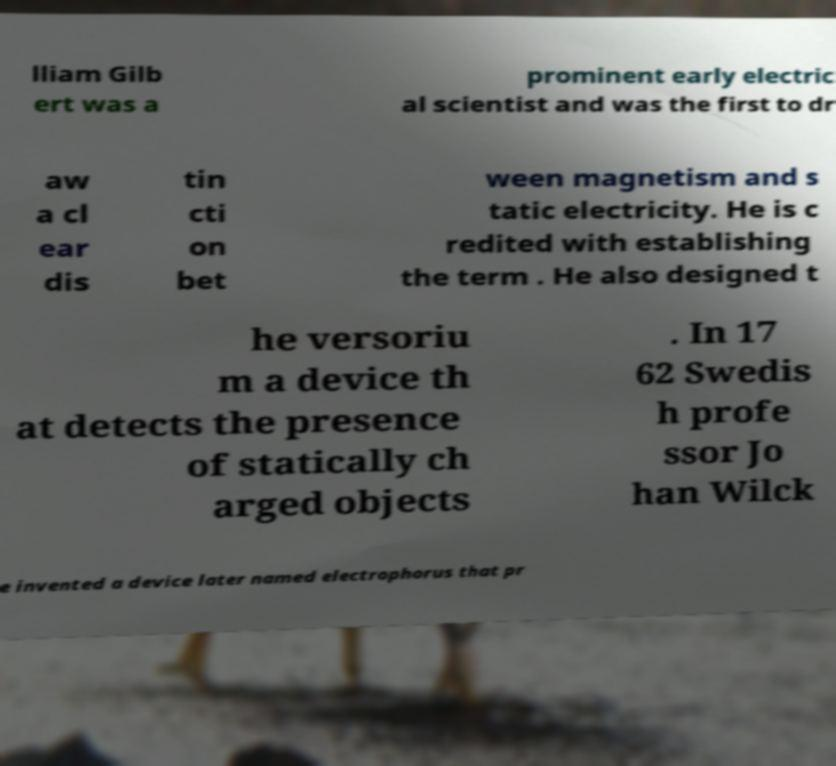For documentation purposes, I need the text within this image transcribed. Could you provide that? lliam Gilb ert was a prominent early electric al scientist and was the first to dr aw a cl ear dis tin cti on bet ween magnetism and s tatic electricity. He is c redited with establishing the term . He also designed t he versoriu m a device th at detects the presence of statically ch arged objects . In 17 62 Swedis h profe ssor Jo han Wilck e invented a device later named electrophorus that pr 